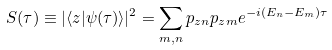<formula> <loc_0><loc_0><loc_500><loc_500>S ( \tau ) \equiv | \langle z | \psi ( \tau ) \rangle | ^ { 2 } = \sum _ { m , n } p _ { z n } p _ { z m } e ^ { - i ( E _ { n } - E _ { m } ) \tau }</formula> 